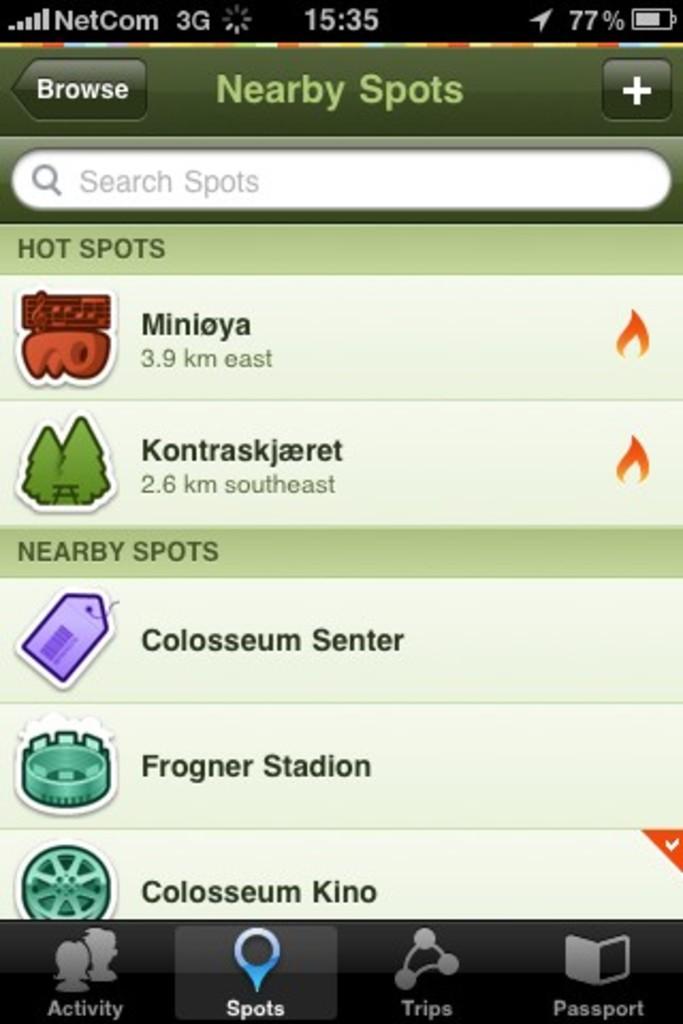What i the app page?
Offer a very short reply. Nearby spots. 